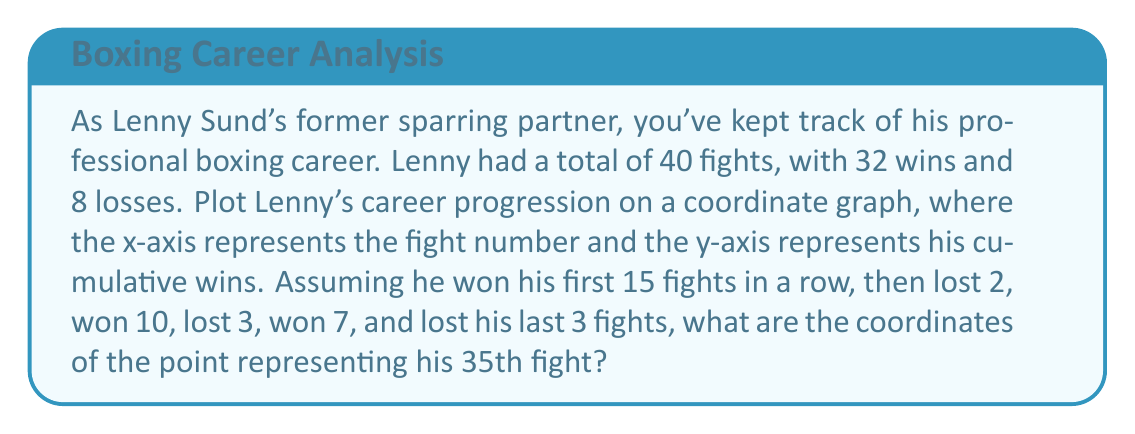What is the answer to this math problem? Let's break this down step-by-step:

1) First, we need to understand how to plot this on a coordinate graph:
   - The x-axis represents the fight number (1 to 40)
   - The y-axis represents the cumulative wins

2) Let's track Lenny's wins:
   - First 15 fights: 15 wins (15-0)
   - Next 2 fights: 2 losses (15-2)
   - Next 10 fights: 10 wins (25-2)
   - Next 3 fights: 3 losses (25-5)
   - Next 7 fights: 7 wins (32-5)
   - Last 3 fights: 3 losses (32-8)

3) We're asked about the 35th fight. Let's count:
   - 15 + 2 + 10 + 3 + 5 = 35

4) This means the 35th fight is the 5th fight in the streak of 7 wins.

5) To find the y-coordinate (cumulative wins):
   - Wins before this streak: 25
   - Wins in this streak up to 35th fight: 5
   - Total wins: 25 + 5 = 30

Therefore, the coordinates of the point representing Lenny's 35th fight are (35, 30).

[asy]
size(200,200);
import graph;

// Draw axes
axes("Fight Number", "Cumulative Wins", (0,0), (45,35), Arrow);

// Plot the career progression
real[] x = {0,15,17,27,30,37,40};
real[] y = {0,15,15,25,25,32,32};
draw(graph(x,y),red);

// Mark the 35th fight
dot((35,30),red);
label("(35,30)",(35,30),NE);
[/asy]
Answer: $$(35, 30)$$ 